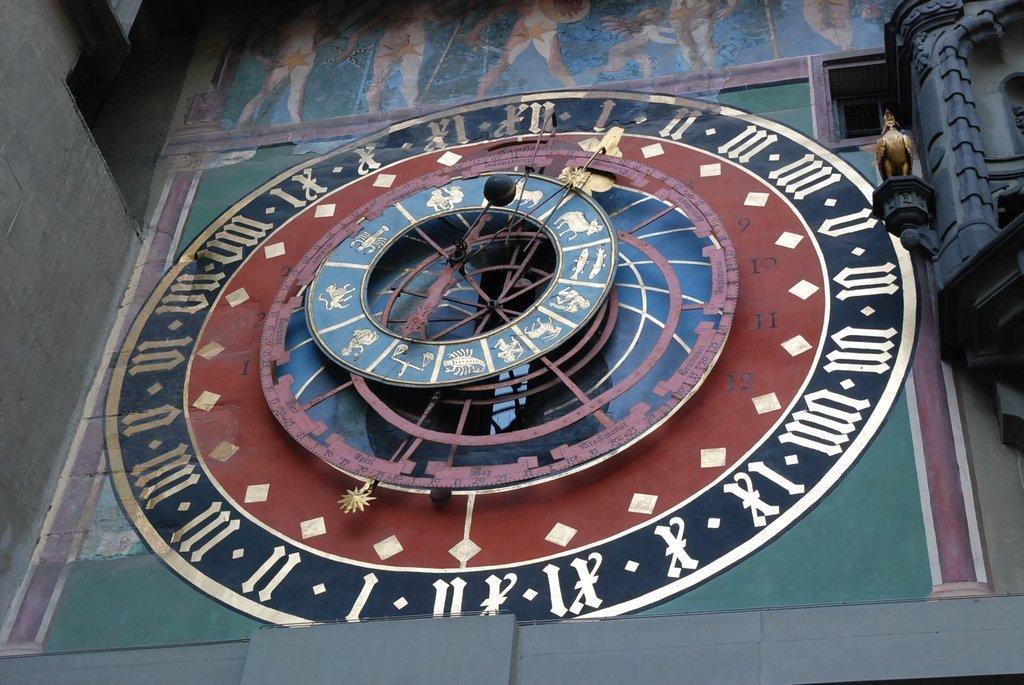Please provide a concise description of this image. In this image I can see a huge clock which is blue, black, maroon and white in color. To the right side of the image I can see a statue which is gold in color of a bird. To the top of the image I can see the painting of few persons. 